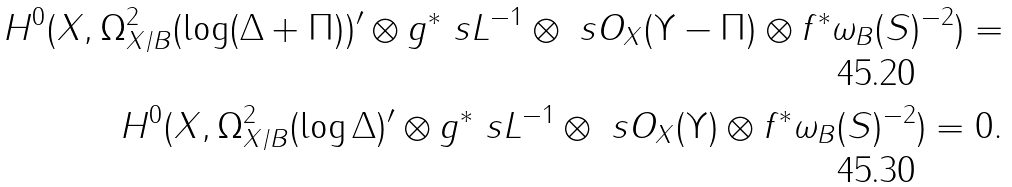<formula> <loc_0><loc_0><loc_500><loc_500>H ^ { 0 } ( X , \Omega ^ { 2 } _ { X / B } ( \log ( \Delta + \Pi ) ) ^ { \prime } \otimes g ^ { * } \ s L ^ { - 1 } \otimes \ s O _ { X } ( \Upsilon - \Pi ) \otimes f ^ { * } \omega _ { B } ( S ) ^ { - 2 } ) = \\ H ^ { 0 } ( X , \Omega ^ { 2 } _ { X / B } ( \log \Delta ) ^ { \prime } \otimes g ^ { * } \ s L ^ { - 1 } \otimes \ s O _ { X } ( \Upsilon ) \otimes f ^ { * } \omega _ { B } ( S ) ^ { - 2 } ) = 0 .</formula> 